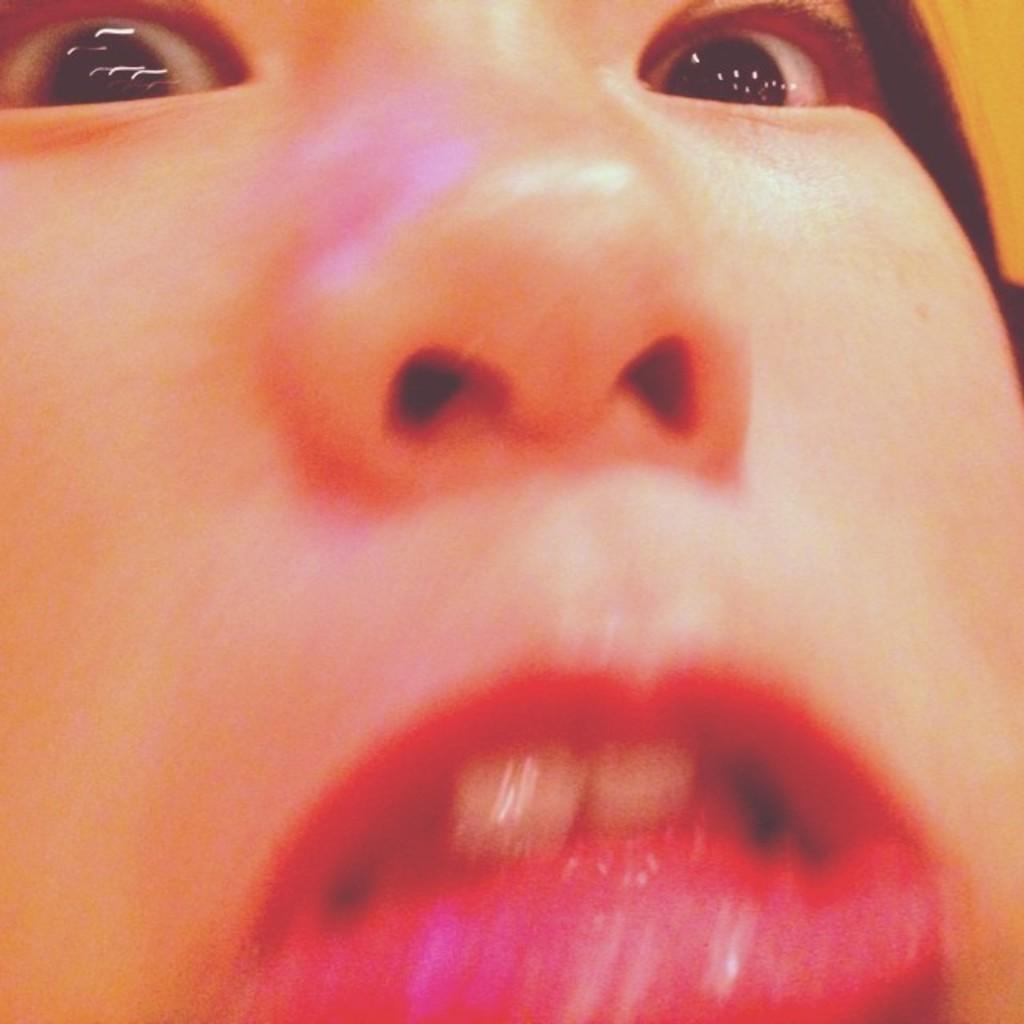In one or two sentences, can you explain what this image depicts? In this image, we can see human face. Here we can see eyes, nose and mouth. 